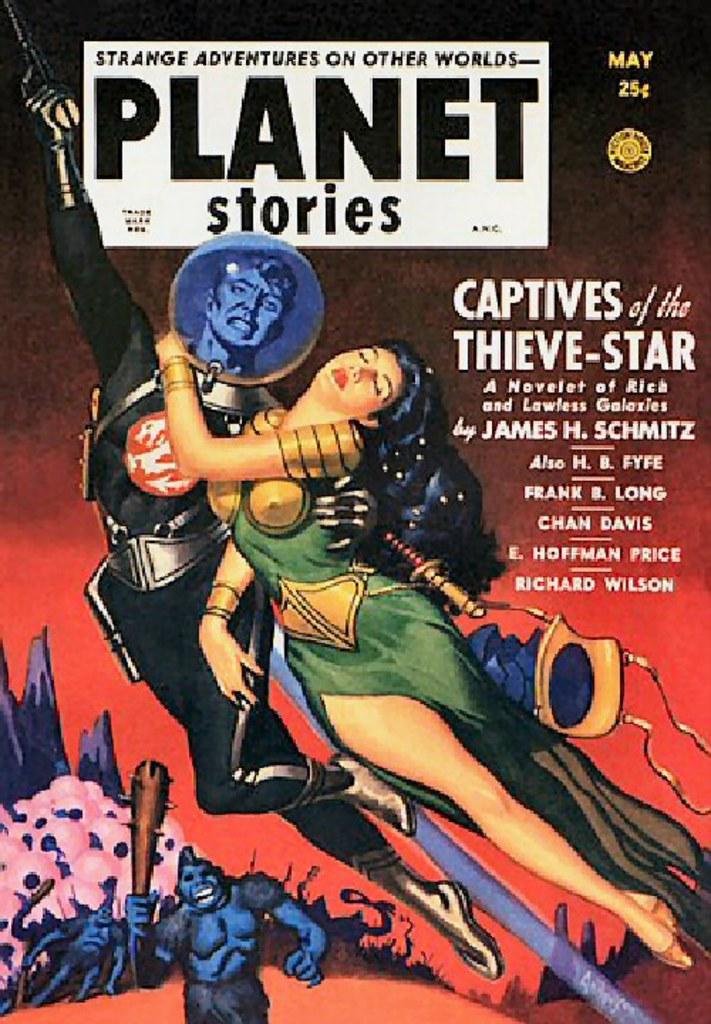Who wrote this comic book?
Give a very brief answer. James h. schmitz. What month was the comic published?
Your answer should be compact. May. 